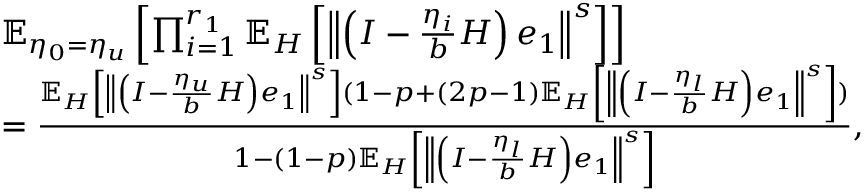Convert formula to latex. <formula><loc_0><loc_0><loc_500><loc_500>\begin{array} { r l } & { \mathbb { E } _ { \eta _ { 0 } = \eta _ { u } } \left [ \prod _ { i = 1 } ^ { r _ { 1 } } \mathbb { E } _ { H } \left [ \left \| \left ( I - \frac { \eta _ { i } } { b } H \right ) e _ { 1 } \right \| ^ { s } \right ] \right ] } \\ & { = \frac { \mathbb { E } _ { H } \left [ \left \| \left ( I - \frac { \eta _ { u } } { b } H \right ) e _ { 1 } \right \| ^ { s } \right ] ( 1 - p + ( 2 p - 1 ) \mathbb { E } _ { H } \left [ \left \| \left ( I - \frac { \eta _ { l } } { b } H \right ) e _ { 1 } \right \| ^ { s } \right ] ) } { 1 - ( 1 - p ) \mathbb { E } _ { H } \left [ \left \| \left ( I - \frac { \eta _ { l } } { b } H \right ) e _ { 1 } \right \| ^ { s } \right ] } , } \end{array}</formula> 